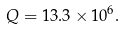Convert formula to latex. <formula><loc_0><loc_0><loc_500><loc_500>Q = 1 3 . 3 \times 1 0 ^ { 6 } .</formula> 